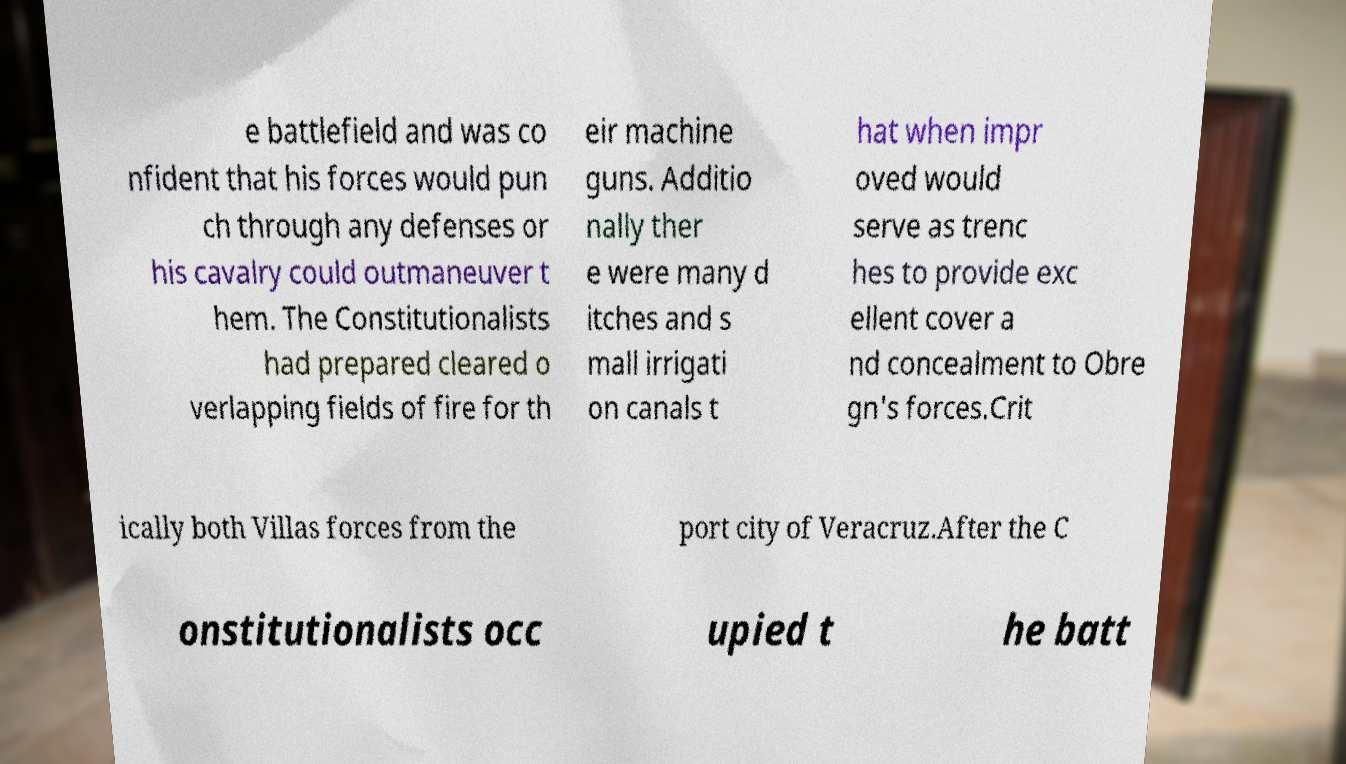Could you assist in decoding the text presented in this image and type it out clearly? e battlefield and was co nfident that his forces would pun ch through any defenses or his cavalry could outmaneuver t hem. The Constitutionalists had prepared cleared o verlapping fields of fire for th eir machine guns. Additio nally ther e were many d itches and s mall irrigati on canals t hat when impr oved would serve as trenc hes to provide exc ellent cover a nd concealment to Obre gn's forces.Crit ically both Villas forces from the port city of Veracruz.After the C onstitutionalists occ upied t he batt 